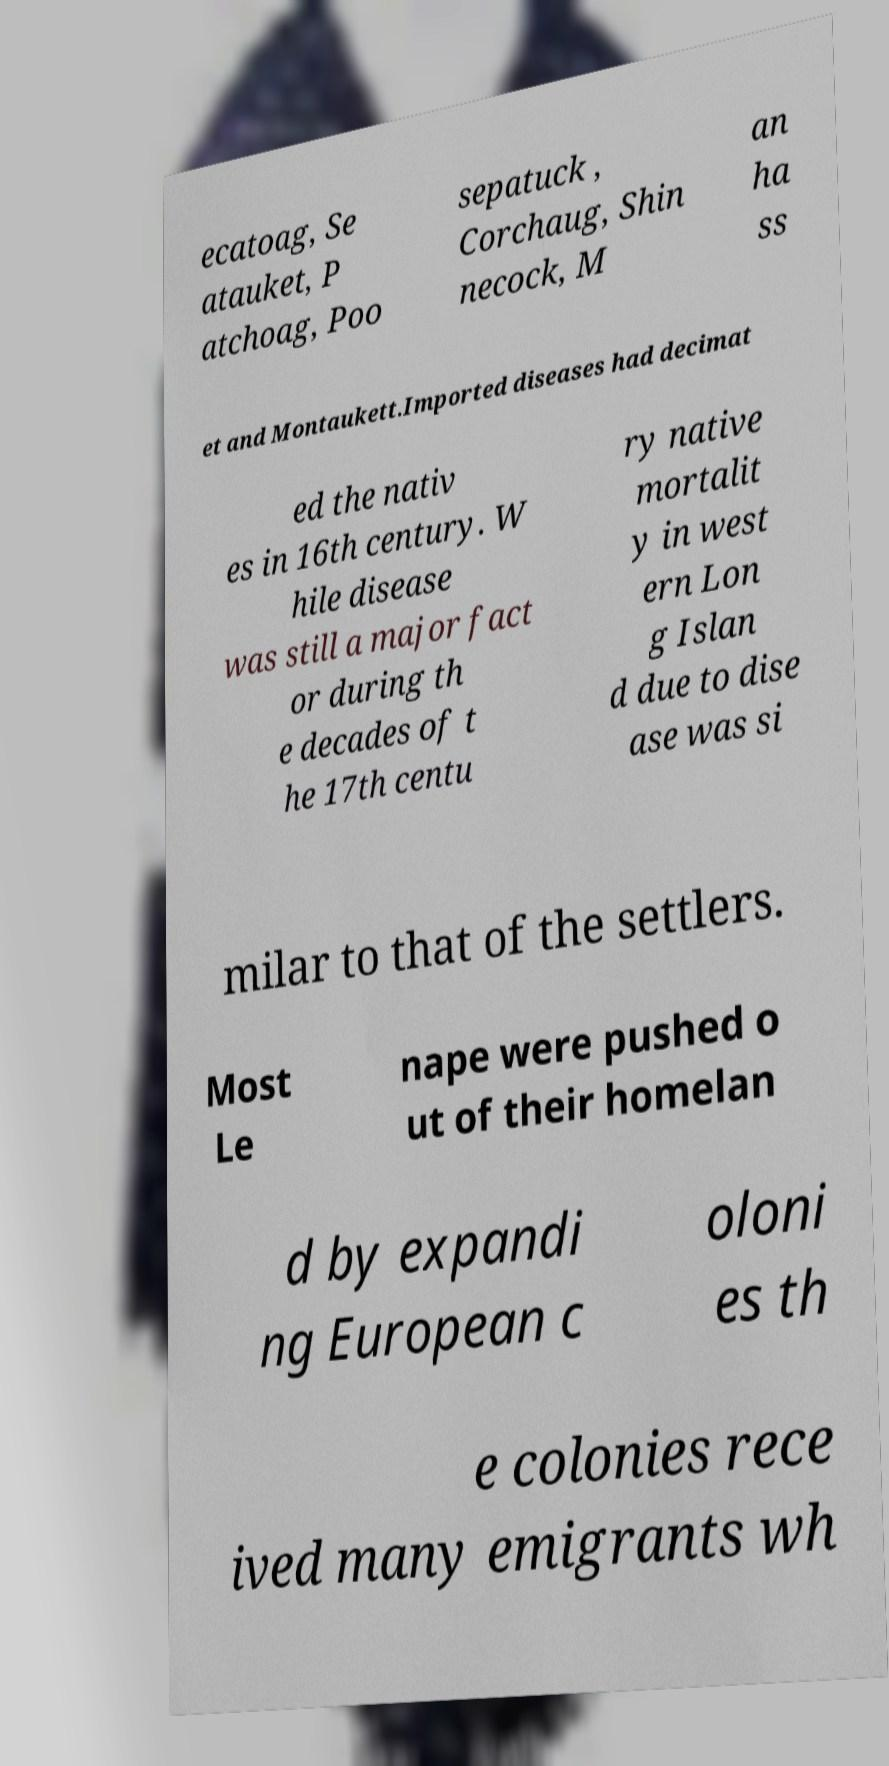What messages or text are displayed in this image? I need them in a readable, typed format. ecatoag, Se atauket, P atchoag, Poo sepatuck , Corchaug, Shin necock, M an ha ss et and Montaukett.Imported diseases had decimat ed the nativ es in 16th century. W hile disease was still a major fact or during th e decades of t he 17th centu ry native mortalit y in west ern Lon g Islan d due to dise ase was si milar to that of the settlers. Most Le nape were pushed o ut of their homelan d by expandi ng European c oloni es th e colonies rece ived many emigrants wh 